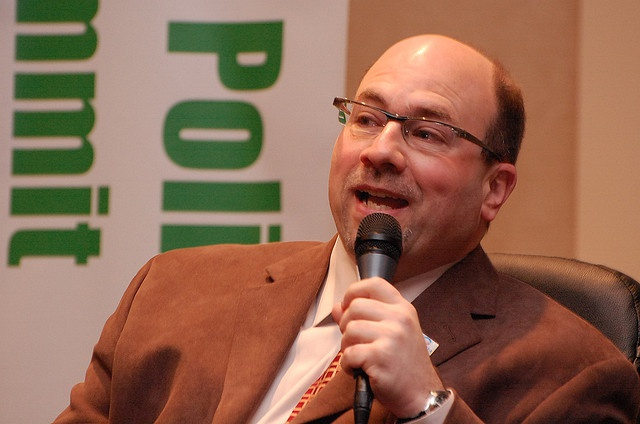Describe the objects in this image and their specific colors. I can see people in gray, maroon, brown, and black tones, chair in gray, maroon, black, and brown tones, and tie in gray, salmon, and brown tones in this image. 